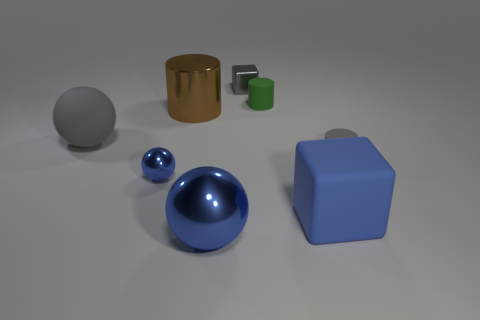There is a small object that is the same material as the small green cylinder; what is its shape?
Offer a terse response. Cylinder. Is the number of cubes that are in front of the tiny gray shiny block less than the number of big blue metal spheres that are to the left of the rubber ball?
Your response must be concise. No. How many tiny objects are either rubber cylinders or brown shiny cylinders?
Provide a succinct answer. 2. Is the shape of the small shiny object that is on the left side of the gray metallic cube the same as the big blue object on the left side of the tiny green rubber object?
Make the answer very short. Yes. What is the size of the gray matte object that is left of the small cylinder in front of the rubber cylinder left of the tiny gray matte cylinder?
Keep it short and to the point. Large. There is a gray thing that is in front of the gray rubber sphere; what is its size?
Provide a short and direct response. Small. There is a object behind the green cylinder; what is it made of?
Make the answer very short. Metal. What number of brown objects are either tiny rubber cylinders or metallic cubes?
Offer a terse response. 0. Do the big gray thing and the ball right of the large brown object have the same material?
Provide a succinct answer. No. Is the number of metal blocks to the right of the green rubber cylinder the same as the number of blue matte blocks to the left of the small gray block?
Your answer should be very brief. Yes. 